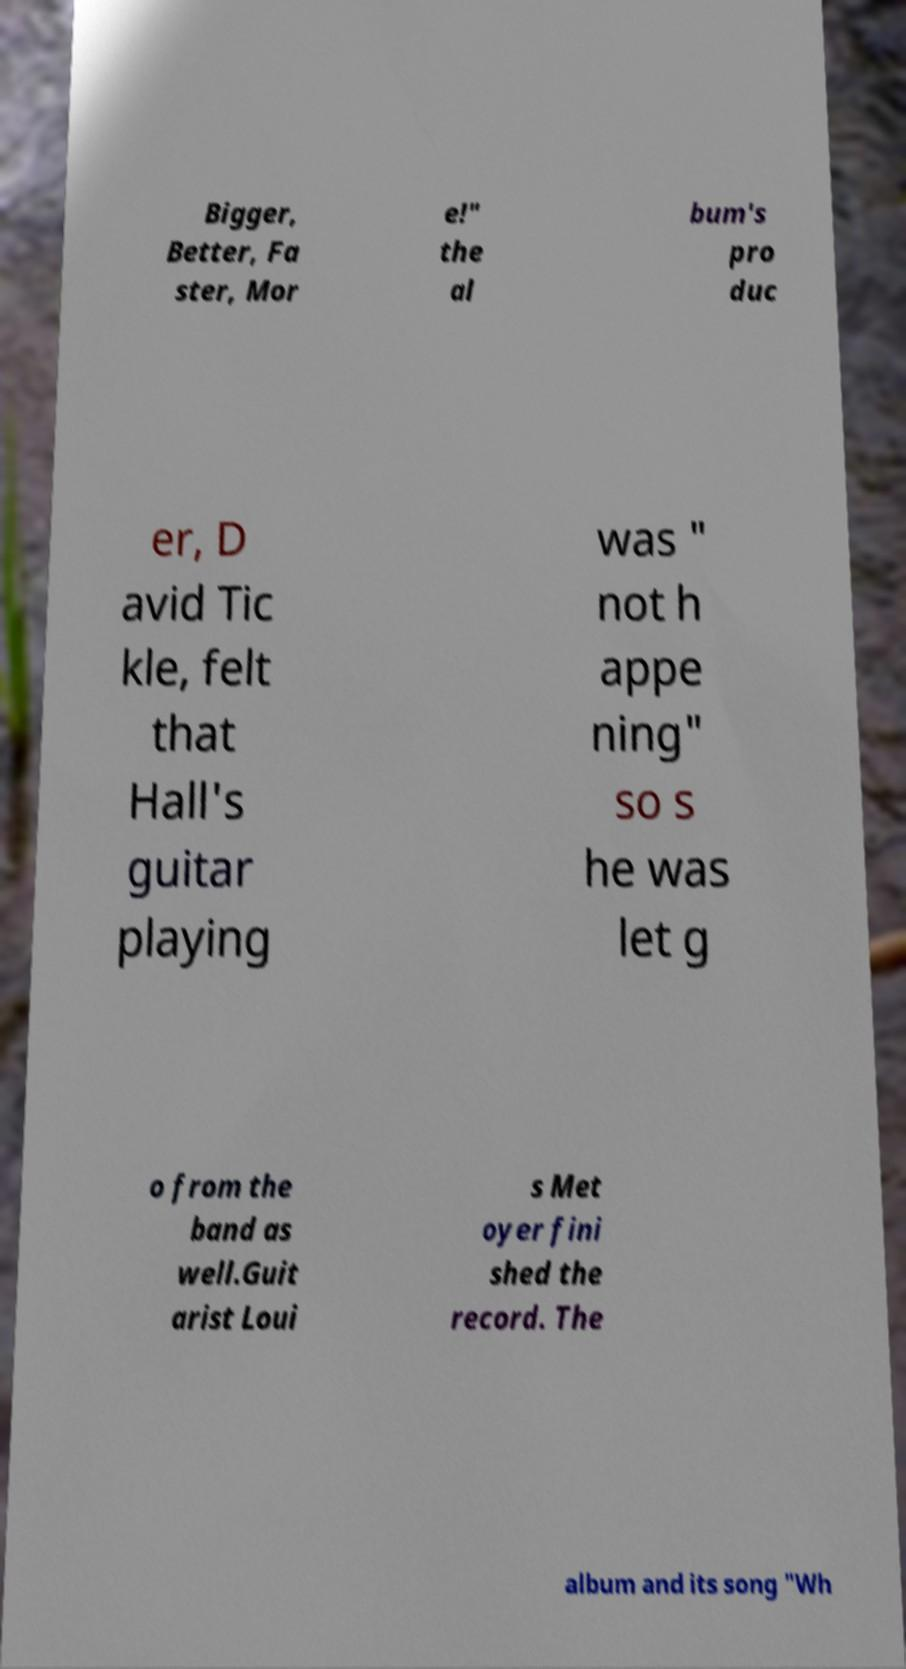Could you extract and type out the text from this image? Bigger, Better, Fa ster, Mor e!" the al bum's pro duc er, D avid Tic kle, felt that Hall's guitar playing was " not h appe ning" so s he was let g o from the band as well.Guit arist Loui s Met oyer fini shed the record. The album and its song "Wh 